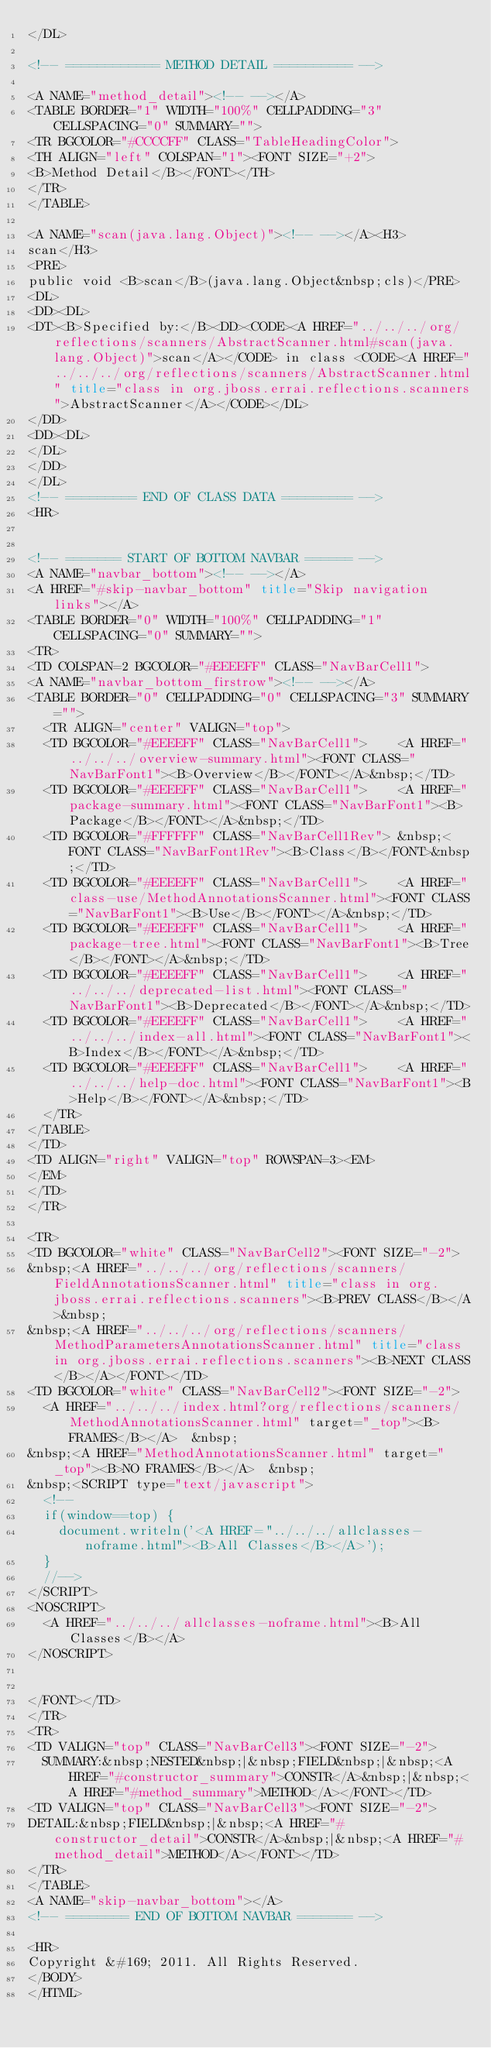Convert code to text. <code><loc_0><loc_0><loc_500><loc_500><_HTML_></DL>

<!-- ============ METHOD DETAIL ========== -->

<A NAME="method_detail"><!-- --></A>
<TABLE BORDER="1" WIDTH="100%" CELLPADDING="3" CELLSPACING="0" SUMMARY="">
<TR BGCOLOR="#CCCCFF" CLASS="TableHeadingColor">
<TH ALIGN="left" COLSPAN="1"><FONT SIZE="+2">
<B>Method Detail</B></FONT></TH>
</TR>
</TABLE>

<A NAME="scan(java.lang.Object)"><!-- --></A><H3>
scan</H3>
<PRE>
public void <B>scan</B>(java.lang.Object&nbsp;cls)</PRE>
<DL>
<DD><DL>
<DT><B>Specified by:</B><DD><CODE><A HREF="../../../org/reflections/scanners/AbstractScanner.html#scan(java.lang.Object)">scan</A></CODE> in class <CODE><A HREF="../../../org/reflections/scanners/AbstractScanner.html" title="class in org.jboss.errai.reflections.scanners">AbstractScanner</A></CODE></DL>
</DD>
<DD><DL>
</DL>
</DD>
</DL>
<!-- ========= END OF CLASS DATA ========= -->
<HR>


<!-- ======= START OF BOTTOM NAVBAR ====== -->
<A NAME="navbar_bottom"><!-- --></A>
<A HREF="#skip-navbar_bottom" title="Skip navigation links"></A>
<TABLE BORDER="0" WIDTH="100%" CELLPADDING="1" CELLSPACING="0" SUMMARY="">
<TR>
<TD COLSPAN=2 BGCOLOR="#EEEEFF" CLASS="NavBarCell1">
<A NAME="navbar_bottom_firstrow"><!-- --></A>
<TABLE BORDER="0" CELLPADDING="0" CELLSPACING="3" SUMMARY="">
  <TR ALIGN="center" VALIGN="top">
  <TD BGCOLOR="#EEEEFF" CLASS="NavBarCell1">    <A HREF="../../../overview-summary.html"><FONT CLASS="NavBarFont1"><B>Overview</B></FONT></A>&nbsp;</TD>
  <TD BGCOLOR="#EEEEFF" CLASS="NavBarCell1">    <A HREF="package-summary.html"><FONT CLASS="NavBarFont1"><B>Package</B></FONT></A>&nbsp;</TD>
  <TD BGCOLOR="#FFFFFF" CLASS="NavBarCell1Rev"> &nbsp;<FONT CLASS="NavBarFont1Rev"><B>Class</B></FONT>&nbsp;</TD>
  <TD BGCOLOR="#EEEEFF" CLASS="NavBarCell1">    <A HREF="class-use/MethodAnnotationsScanner.html"><FONT CLASS="NavBarFont1"><B>Use</B></FONT></A>&nbsp;</TD>
  <TD BGCOLOR="#EEEEFF" CLASS="NavBarCell1">    <A HREF="package-tree.html"><FONT CLASS="NavBarFont1"><B>Tree</B></FONT></A>&nbsp;</TD>
  <TD BGCOLOR="#EEEEFF" CLASS="NavBarCell1">    <A HREF="../../../deprecated-list.html"><FONT CLASS="NavBarFont1"><B>Deprecated</B></FONT></A>&nbsp;</TD>
  <TD BGCOLOR="#EEEEFF" CLASS="NavBarCell1">    <A HREF="../../../index-all.html"><FONT CLASS="NavBarFont1"><B>Index</B></FONT></A>&nbsp;</TD>
  <TD BGCOLOR="#EEEEFF" CLASS="NavBarCell1">    <A HREF="../../../help-doc.html"><FONT CLASS="NavBarFont1"><B>Help</B></FONT></A>&nbsp;</TD>
  </TR>
</TABLE>
</TD>
<TD ALIGN="right" VALIGN="top" ROWSPAN=3><EM>
</EM>
</TD>
</TR>

<TR>
<TD BGCOLOR="white" CLASS="NavBarCell2"><FONT SIZE="-2">
&nbsp;<A HREF="../../../org/reflections/scanners/FieldAnnotationsScanner.html" title="class in org.jboss.errai.reflections.scanners"><B>PREV CLASS</B></A>&nbsp;
&nbsp;<A HREF="../../../org/reflections/scanners/MethodParametersAnnotationsScanner.html" title="class in org.jboss.errai.reflections.scanners"><B>NEXT CLASS</B></A></FONT></TD>
<TD BGCOLOR="white" CLASS="NavBarCell2"><FONT SIZE="-2">
  <A HREF="../../../index.html?org/reflections/scanners/MethodAnnotationsScanner.html" target="_top"><B>FRAMES</B></A>  &nbsp;
&nbsp;<A HREF="MethodAnnotationsScanner.html" target="_top"><B>NO FRAMES</B></A>  &nbsp;
&nbsp;<SCRIPT type="text/javascript">
  <!--
  if(window==top) {
    document.writeln('<A HREF="../../../allclasses-noframe.html"><B>All Classes</B></A>');
  }
  //-->
</SCRIPT>
<NOSCRIPT>
  <A HREF="../../../allclasses-noframe.html"><B>All Classes</B></A>
</NOSCRIPT>


</FONT></TD>
</TR>
<TR>
<TD VALIGN="top" CLASS="NavBarCell3"><FONT SIZE="-2">
  SUMMARY:&nbsp;NESTED&nbsp;|&nbsp;FIELD&nbsp;|&nbsp;<A HREF="#constructor_summary">CONSTR</A>&nbsp;|&nbsp;<A HREF="#method_summary">METHOD</A></FONT></TD>
<TD VALIGN="top" CLASS="NavBarCell3"><FONT SIZE="-2">
DETAIL:&nbsp;FIELD&nbsp;|&nbsp;<A HREF="#constructor_detail">CONSTR</A>&nbsp;|&nbsp;<A HREF="#method_detail">METHOD</A></FONT></TD>
</TR>
</TABLE>
<A NAME="skip-navbar_bottom"></A>
<!-- ======== END OF BOTTOM NAVBAR ======= -->

<HR>
Copyright &#169; 2011. All Rights Reserved.
</BODY>
</HTML>
</code> 